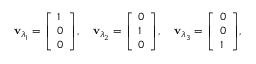<formula> <loc_0><loc_0><loc_500><loc_500>v _ { \lambda _ { 1 } } = { \left [ \begin{array} { l } { 1 } \\ { 0 } \\ { 0 } \end{array} \right ] } , \quad v _ { \lambda _ { 2 } } = { \left [ \begin{array} { l } { 0 } \\ { 1 } \\ { 0 } \end{array} \right ] } , \quad v _ { \lambda _ { 3 } } = { \left [ \begin{array} { l } { 0 } \\ { 0 } \\ { 1 } \end{array} \right ] } ,</formula> 